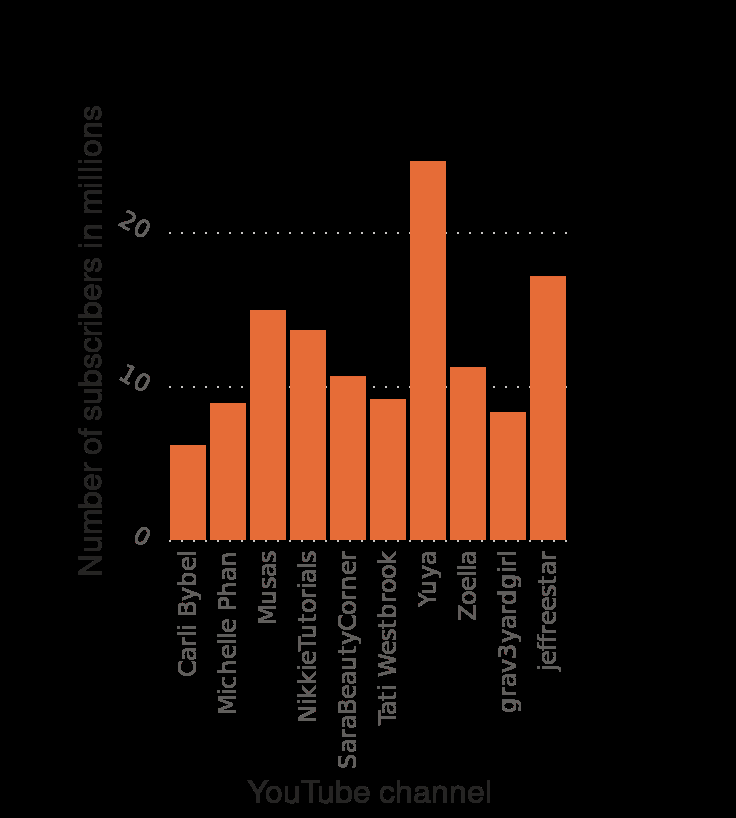<image>
How many individuals are at a similar level as Yuya? There are three other individuals at a similar level as Yuya. Describe the following image in detail Here a is a bar graph named Most popular YouTube beauty and style channels as of October 2020 , ranked by number of subscribers (in millions). The x-axis plots YouTube channel. Along the y-axis, Number of subscribers in millions is defined on a linear scale of range 0 to 20. 